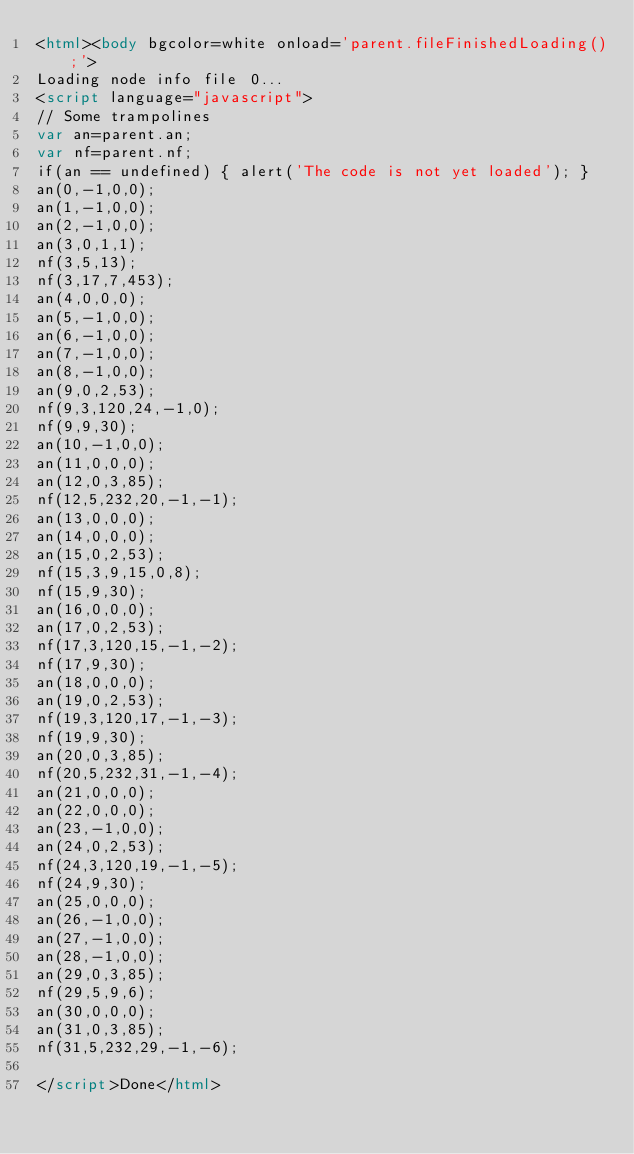<code> <loc_0><loc_0><loc_500><loc_500><_HTML_><html><body bgcolor=white onload='parent.fileFinishedLoading();'>
Loading node info file 0...
<script language="javascript">
// Some trampolines
var an=parent.an;
var nf=parent.nf;
if(an == undefined) { alert('The code is not yet loaded'); }
an(0,-1,0,0);
an(1,-1,0,0);
an(2,-1,0,0);
an(3,0,1,1);
nf(3,5,13);
nf(3,17,7,453);
an(4,0,0,0);
an(5,-1,0,0);
an(6,-1,0,0);
an(7,-1,0,0);
an(8,-1,0,0);
an(9,0,2,53);
nf(9,3,120,24,-1,0);
nf(9,9,30);
an(10,-1,0,0);
an(11,0,0,0);
an(12,0,3,85);
nf(12,5,232,20,-1,-1);
an(13,0,0,0);
an(14,0,0,0);
an(15,0,2,53);
nf(15,3,9,15,0,8);
nf(15,9,30);
an(16,0,0,0);
an(17,0,2,53);
nf(17,3,120,15,-1,-2);
nf(17,9,30);
an(18,0,0,0);
an(19,0,2,53);
nf(19,3,120,17,-1,-3);
nf(19,9,30);
an(20,0,3,85);
nf(20,5,232,31,-1,-4);
an(21,0,0,0);
an(22,0,0,0);
an(23,-1,0,0);
an(24,0,2,53);
nf(24,3,120,19,-1,-5);
nf(24,9,30);
an(25,0,0,0);
an(26,-1,0,0);
an(27,-1,0,0);
an(28,-1,0,0);
an(29,0,3,85);
nf(29,5,9,6);
an(30,0,0,0);
an(31,0,3,85);
nf(31,5,232,29,-1,-6);

</script>Done</html></code> 